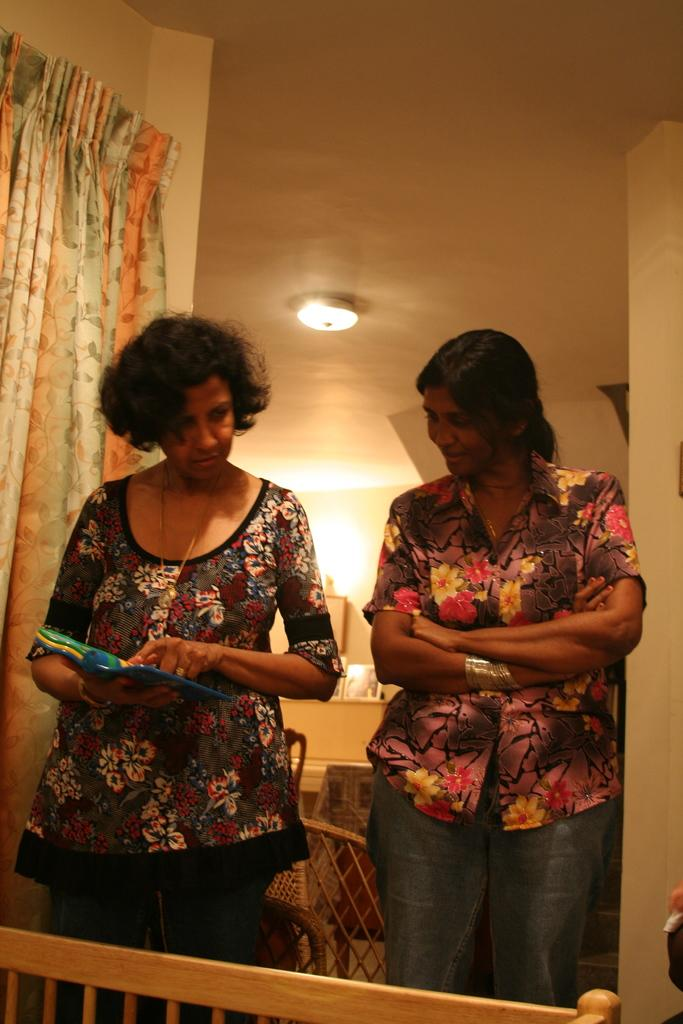How many people are in the image? There are people in the image, but the exact number is not specified. What is one of the people holding? One of the people is holding a book. Can you describe the background of the image? There are objects in the background of the image, but their specific nature is not mentioned. What is the purpose of the railing in the image? The purpose of the railing in the image is not clear, but it could be for safety or decoration. What is the curtain used for in the image? The curtain is likely used for privacy or to control light in the room. What is the source of light in the image? There is a light in the image, but its type or location is not specified. What is the wall used for in the image? The wall is likely used for structural support and as a surface for hanging objects or decorations. What direction does the leaf blow in the image? There is no leaf present in the image, so it cannot be determined in which direction it would blow. 